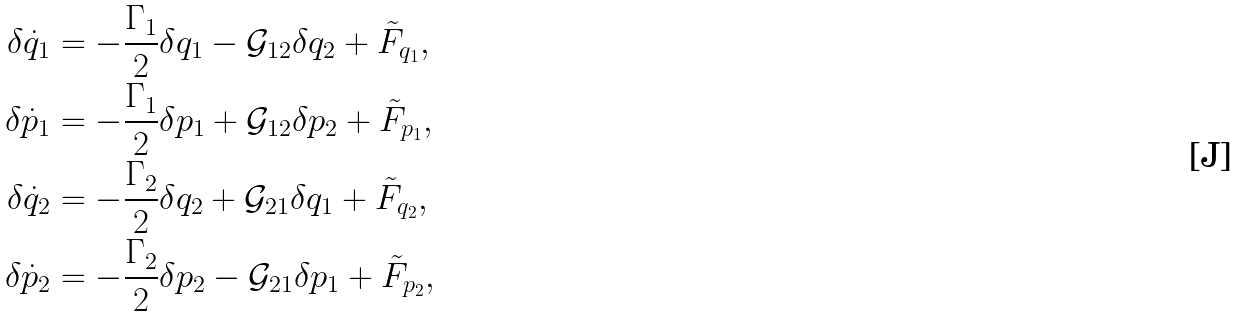Convert formula to latex. <formula><loc_0><loc_0><loc_500><loc_500>\delta \dot { q } _ { 1 } & = - \frac { \Gamma _ { 1 } } { 2 } \delta q _ { 1 } - \mathcal { G } _ { 1 2 } \delta q _ { 2 } + \tilde { F } _ { q _ { 1 } } , \\ \delta \dot { p } _ { 1 } & = - \frac { \Gamma _ { 1 } } { 2 } \delta p _ { 1 } + \mathcal { G } _ { 1 2 } \delta p _ { 2 } + \tilde { F } _ { p _ { 1 } } , \\ \delta \dot { q } _ { 2 } & = - \frac { \Gamma _ { 2 } } { 2 } \delta q _ { 2 } + \mathcal { G } _ { 2 1 } \delta q _ { 1 } + \tilde { F } _ { q _ { 2 } } , \\ \delta \dot { p } _ { 2 } & = - \frac { \Gamma _ { 2 } } { 2 } \delta p _ { 2 } - \mathcal { G } _ { 2 1 } \delta p _ { 1 } + \tilde { F } _ { p _ { 2 } } ,</formula> 